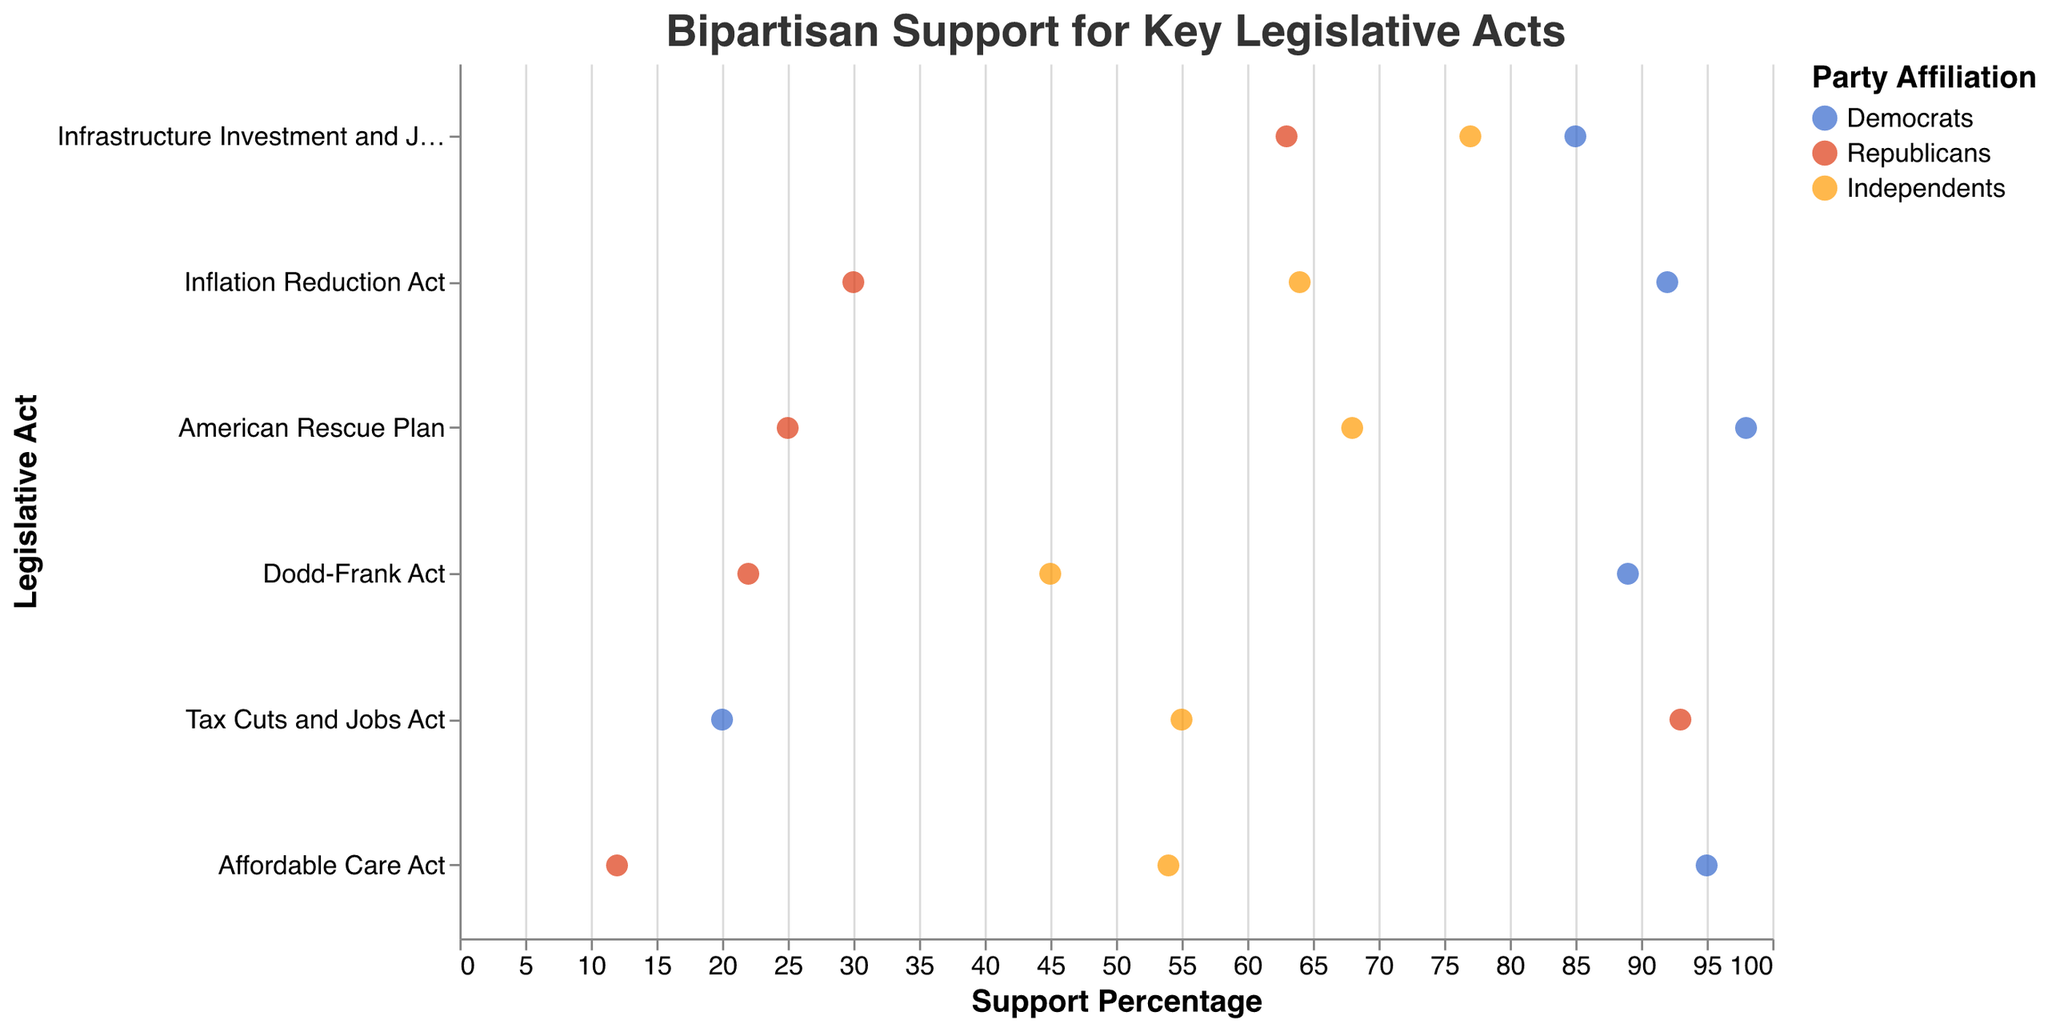What's the title of the figure? The title of the figure is displayed at the top and reads "Bipartisan Support for Key Legislative Acts."
Answer: Bipartisan Support for Key Legislative Acts Which legislative act has the highest support from Democrats? From the plot, the legislative act with the highest dot for Democrats is the "American Rescue Plan" at 98%.
Answer: American Rescue Plan What is the support percentage for the Inflation Reduction Act among Independents? Independents' support for the Inflation Reduction Act can be identified by looking for the dot color representing Independents (orange) next to the "Inflation Reduction Act" on the y-axis. The percentage is 64%.
Answer: 64% Compare the support percentage of the Affordable Care Act between Republicans and Independents. Find the Affordable Care Act on the y-axis and compare the red dot (Republicans) and orange dot (Independents). Republicans have 12%, and Independents have 54%.
Answer: Independents' support is higher What is the range of support percentages for the Dodd-Frank Act? The range can be found by identifying the minimum and maximum support for the Dodd-Frank Act. Democrats: 89%, Republicans: 22%, and Independents: 45%. The range is from 22% to 89%.
Answer: 22% to 89% Between which Acts is the support difference highest for Democrats? Calculate the differences in support percentages among acts for Democrats. The significant differences are between the Affordable Care Act (95%) and the Tax Cuts and Jobs Act (20%), yielding the highest difference of 75%.
Answer: Affordable Care Act and Tax Cuts and Jobs Act Which act has the closest bipartisan support among all three parties? Identify the act where the colored dots (Democrats, Republicans, and Independents) are closest together. The Infrastructure Investment and Jobs Act has close support: Democrats 85%, Republicans 63%, and Independents 77%.
Answer: Infrastructure Investment and Jobs Act How does Republican support for the American Rescue Plan compare to their support for the Tax Cuts and Jobs Act? Locate Republican support (red dots) for both acts. The American Rescue Plan has 25% support, while the Tax Cuts and Jobs Act has 93%.
Answer: The Tax Cuts and Jobs Act has much higher support What is the average support percentage for the Affordable Care Act across all parties? Add the support percentages for the Affordable Care Act (Democrats: 95%, Republicans: 12%, Independents: 54%) and divide by three: (95 + 12 + 54) / 3 = 161 / 3 ≈ 53.67%.
Answer: 53.67% 